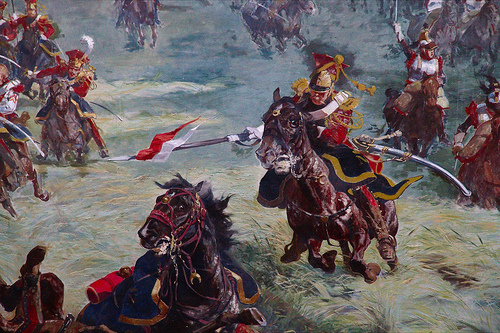<image>
Is the hat on the soldier? No. The hat is not positioned on the soldier. They may be near each other, but the hat is not supported by or resting on top of the soldier. 